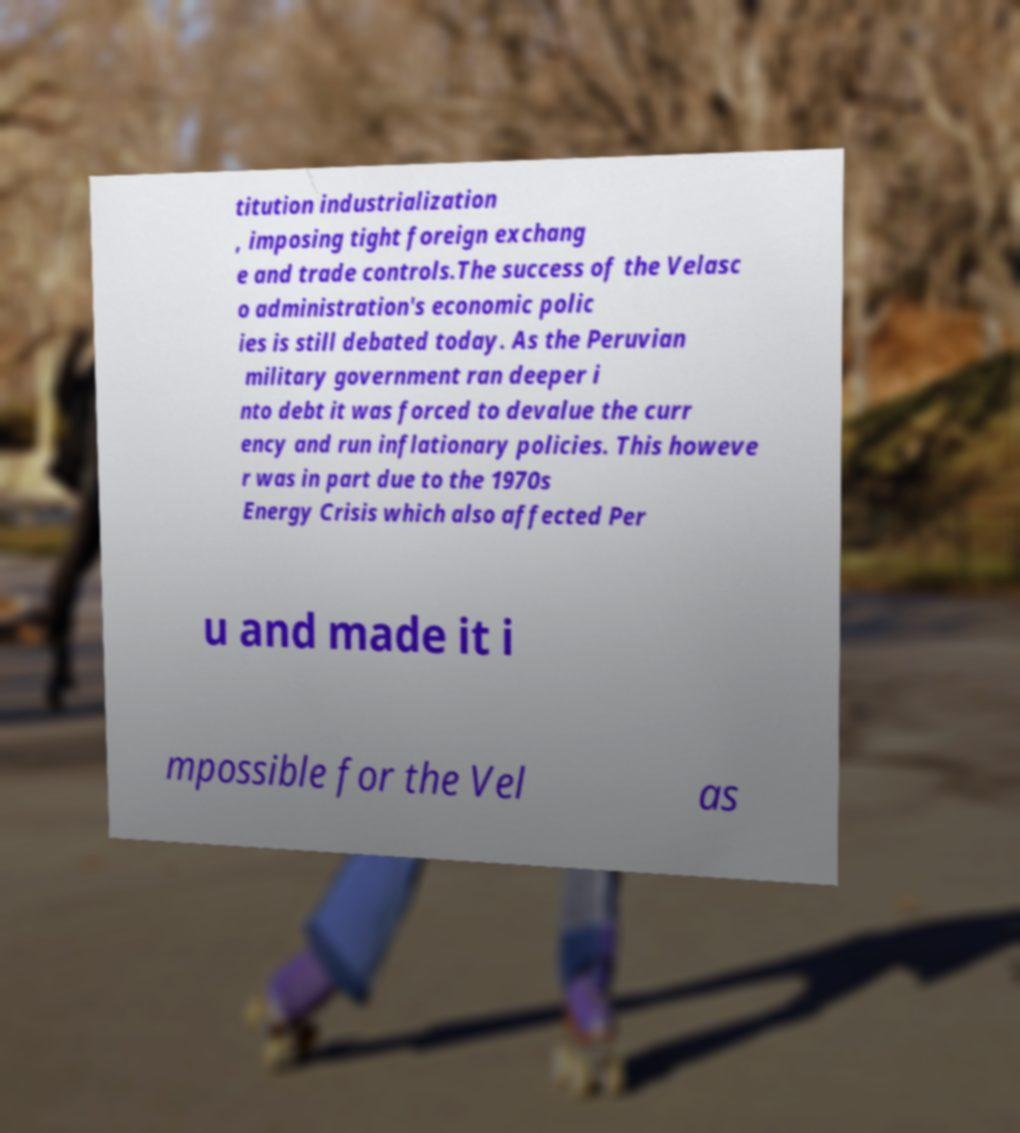There's text embedded in this image that I need extracted. Can you transcribe it verbatim? titution industrialization , imposing tight foreign exchang e and trade controls.The success of the Velasc o administration's economic polic ies is still debated today. As the Peruvian military government ran deeper i nto debt it was forced to devalue the curr ency and run inflationary policies. This howeve r was in part due to the 1970s Energy Crisis which also affected Per u and made it i mpossible for the Vel as 